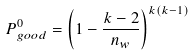Convert formula to latex. <formula><loc_0><loc_0><loc_500><loc_500>P _ { g o o d } ^ { 0 } = \left ( 1 - \frac { k - 2 } { n _ { w } } \right ) ^ { k ( k - 1 ) }</formula> 